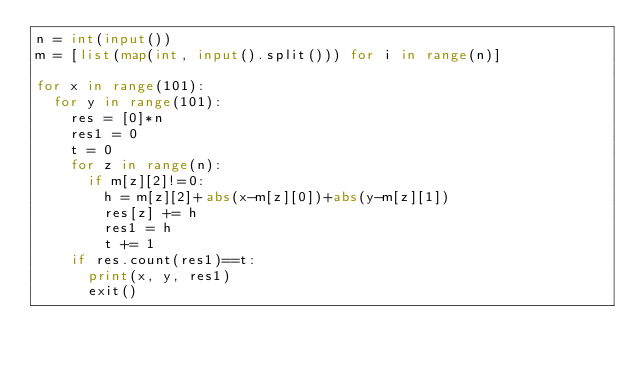<code> <loc_0><loc_0><loc_500><loc_500><_Python_>n = int(input())
m = [list(map(int, input().split())) for i in range(n)]

for x in range(101):
  for y in range(101):
    res = [0]*n
    res1 = 0
    t = 0
    for z in range(n):
      if m[z][2]!=0:
        h = m[z][2]+abs(x-m[z][0])+abs(y-m[z][1])
        res[z] += h
        res1 = h
        t += 1
    if res.count(res1)==t:
      print(x, y, res1)
      exit()</code> 